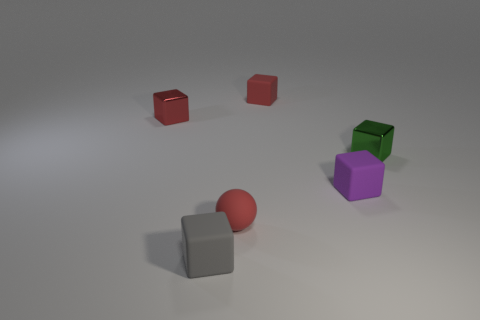Which objects in the image are closest to each other? The two small red cubes seem to be the closest to each other compared to any other pair of objects in the image. 